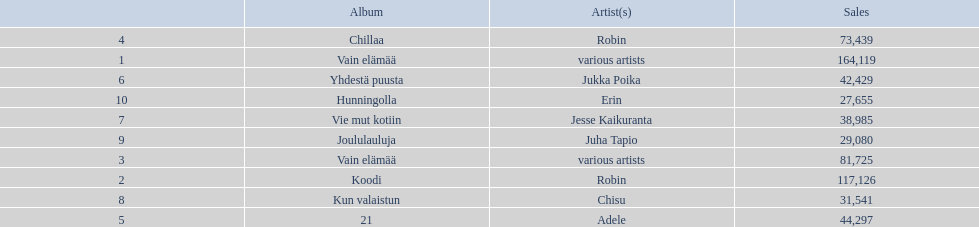Which album had the least amount of sales? Hunningolla. 